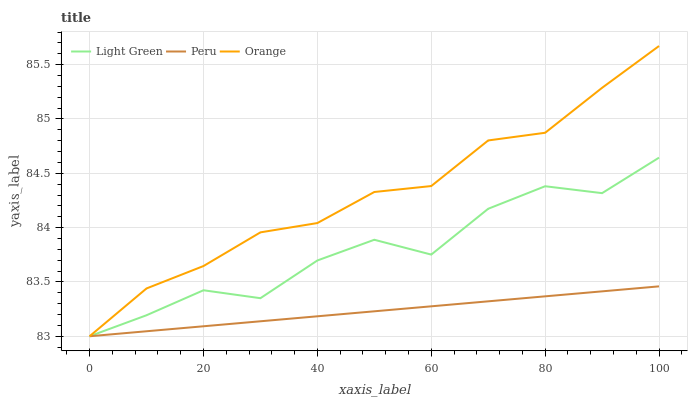Does Peru have the minimum area under the curve?
Answer yes or no. Yes. Does Orange have the maximum area under the curve?
Answer yes or no. Yes. Does Light Green have the minimum area under the curve?
Answer yes or no. No. Does Light Green have the maximum area under the curve?
Answer yes or no. No. Is Peru the smoothest?
Answer yes or no. Yes. Is Light Green the roughest?
Answer yes or no. Yes. Is Light Green the smoothest?
Answer yes or no. No. Is Peru the roughest?
Answer yes or no. No. Does Orange have the lowest value?
Answer yes or no. Yes. Does Orange have the highest value?
Answer yes or no. Yes. Does Light Green have the highest value?
Answer yes or no. No. Does Orange intersect Peru?
Answer yes or no. Yes. Is Orange less than Peru?
Answer yes or no. No. Is Orange greater than Peru?
Answer yes or no. No. 